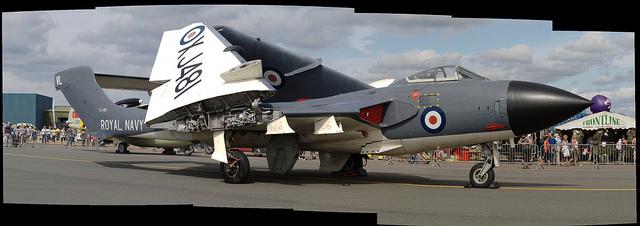Is this a presidential landing?
Answer briefly. No. What number is here?
Answer briefly. 481. What color is the plane?
Answer briefly. Gray. Where was the photo taken?
Be succinct. At airport. Is this plane in flight?
Quick response, please. No. 